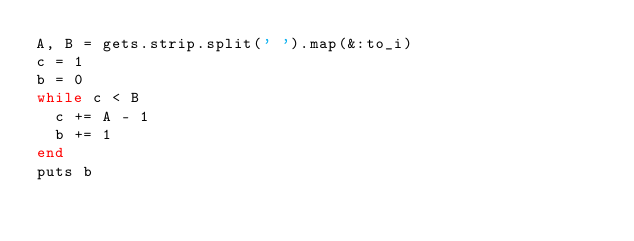<code> <loc_0><loc_0><loc_500><loc_500><_Ruby_>A, B = gets.strip.split(' ').map(&:to_i)
c = 1
b = 0
while c < B
  c += A - 1
  b += 1
end
puts b</code> 